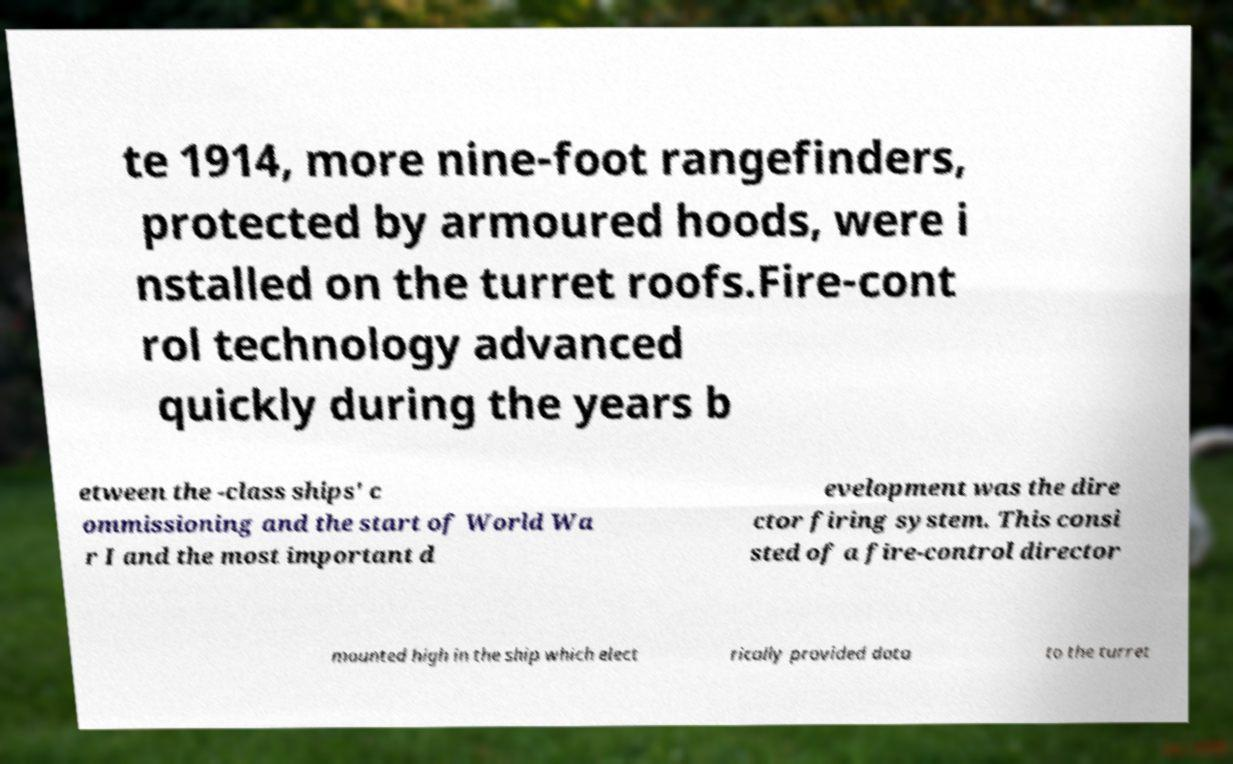There's text embedded in this image that I need extracted. Can you transcribe it verbatim? te 1914, more nine-foot rangefinders, protected by armoured hoods, were i nstalled on the turret roofs.Fire-cont rol technology advanced quickly during the years b etween the -class ships' c ommissioning and the start of World Wa r I and the most important d evelopment was the dire ctor firing system. This consi sted of a fire-control director mounted high in the ship which elect rically provided data to the turret 